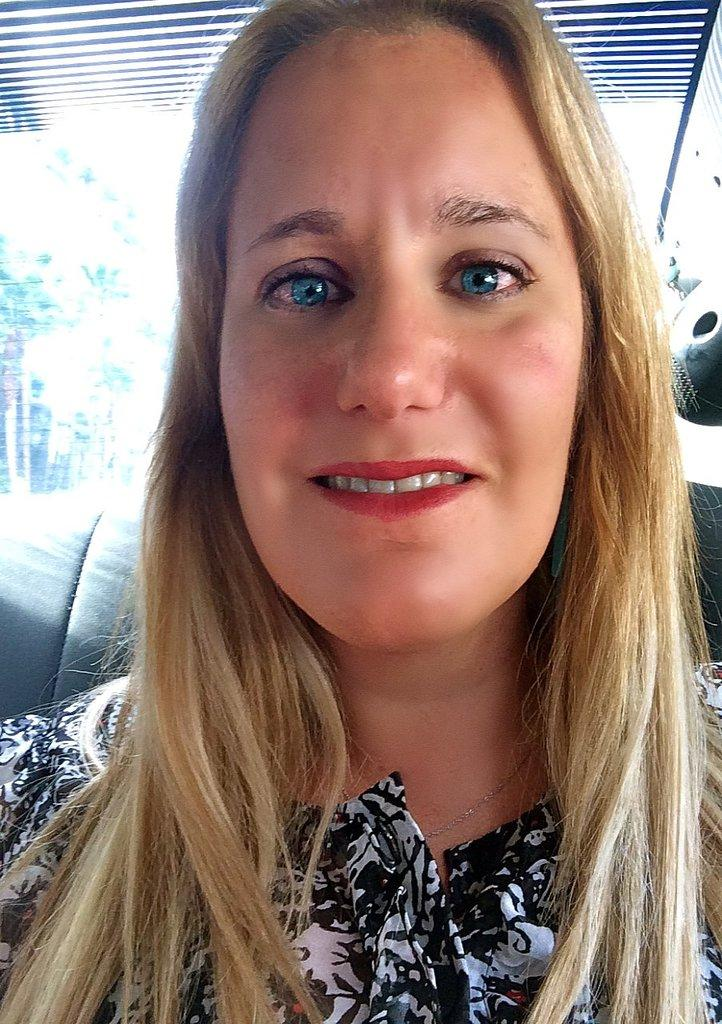What is the person in the image doing? There is a person sitting in the image. What can be seen in the background of the image? There is glass visible in the background of the image. What is located on the right side of the image? There is an object on the right side of the image. What type of cork can be seen floating in the milk in the image? There is no cork or milk present in the image. How many beams are visible in the image? There is no beam present in the image. 